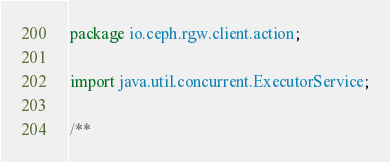Convert code to text. <code><loc_0><loc_0><loc_500><loc_500><_Java_>package io.ceph.rgw.client.action;

import java.util.concurrent.ExecutorService;

/**</code> 